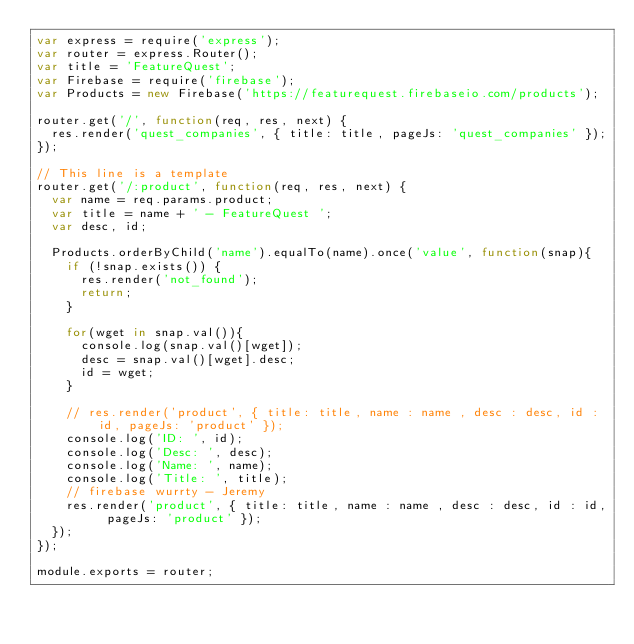Convert code to text. <code><loc_0><loc_0><loc_500><loc_500><_JavaScript_>var express = require('express');
var router = express.Router();
var title = 'FeatureQuest';
var Firebase = require('firebase');
var Products = new Firebase('https://featurequest.firebaseio.com/products');

router.get('/', function(req, res, next) {
  res.render('quest_companies', { title: title, pageJs: 'quest_companies' });
});

// This line is a template
router.get('/:product', function(req, res, next) {
  var name = req.params.product;
  var title = name + ' - FeatureQuest ';
  var desc, id;

  Products.orderByChild('name').equalTo(name).once('value', function(snap){
    if (!snap.exists()) {
      res.render('not_found');
      return;
    }

    for(wget in snap.val()){
      console.log(snap.val()[wget]);
      desc = snap.val()[wget].desc;
      id = wget;
    }

    // res.render('product', { title: title, name : name , desc : desc, id : id, pageJs: 'product' });
    console.log('ID: ', id);
    console.log('Desc: ', desc);
    console.log('Name: ', name);
    console.log('Title: ', title);
    // firebase wurrty - Jeremy
    res.render('product', { title: title, name : name , desc : desc, id : id, pageJs: 'product' });
  });
});

module.exports = router;
</code> 